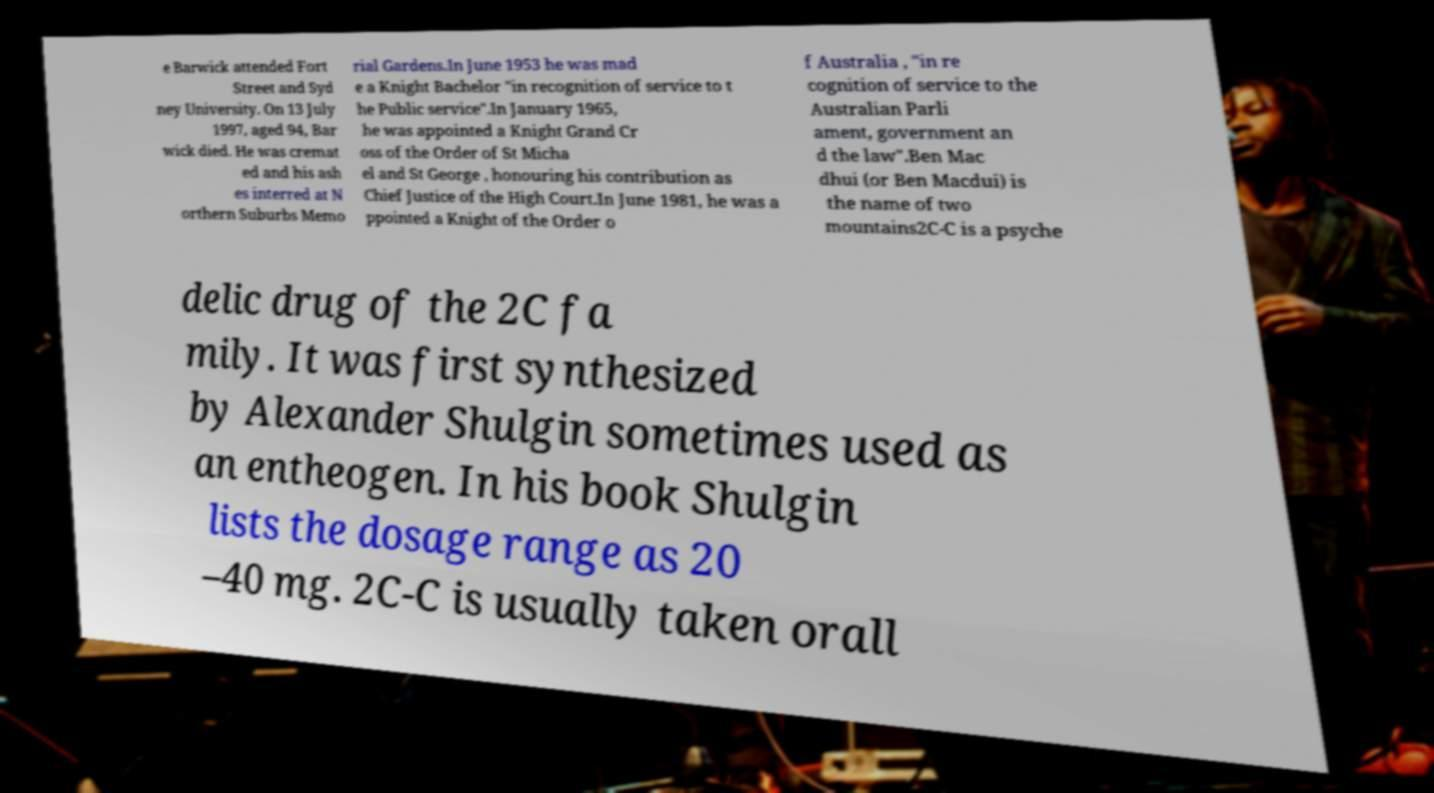For documentation purposes, I need the text within this image transcribed. Could you provide that? e Barwick attended Fort Street and Syd ney University. On 13 July 1997, aged 94, Bar wick died. He was cremat ed and his ash es interred at N orthern Suburbs Memo rial Gardens.In June 1953 he was mad e a Knight Bachelor "in recognition of service to t he Public service".In January 1965, he was appointed a Knight Grand Cr oss of the Order of St Micha el and St George , honouring his contribution as Chief Justice of the High Court.In June 1981, he was a ppointed a Knight of the Order o f Australia , "in re cognition of service to the Australian Parli ament, government an d the law".Ben Mac dhui (or Ben Macdui) is the name of two mountains2C-C is a psyche delic drug of the 2C fa mily. It was first synthesized by Alexander Shulgin sometimes used as an entheogen. In his book Shulgin lists the dosage range as 20 –40 mg. 2C-C is usually taken orall 